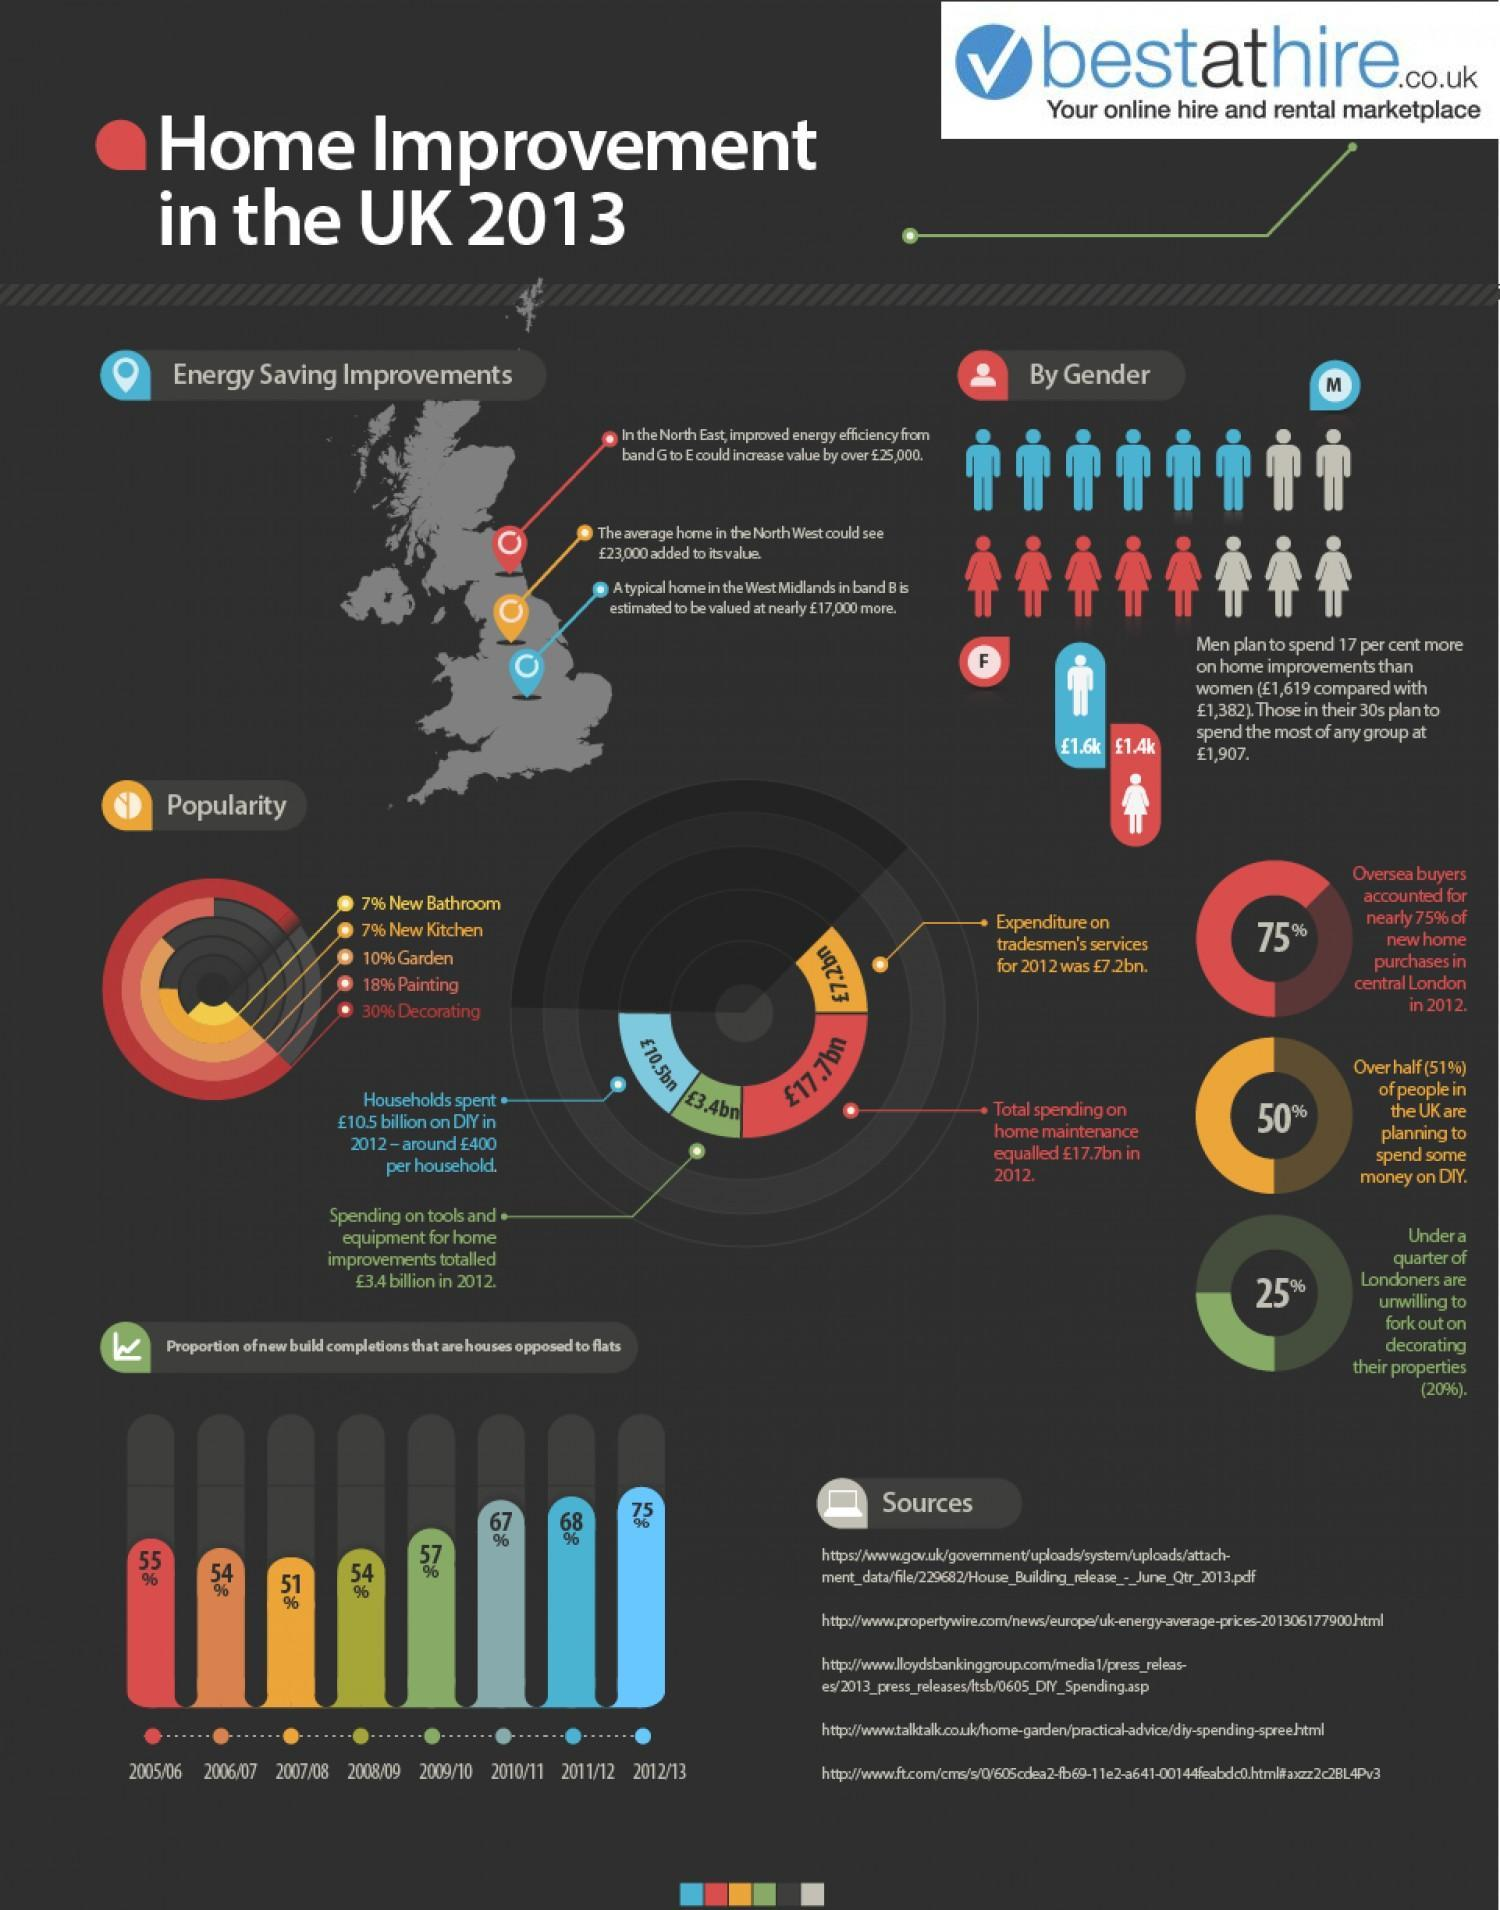What spending came to a total of 17.7 billion pounds in 2012?
Answer the question with a short phrase. home maintenance What was the second most commonly done work in home improvement? Painting Under 25% of Londoners are reluctant to spend money on what? decorating their properties In 2012, how many pounds were spent on tradesmen's services in UK? 7.2bn People in which age group are most likely to spend more money on home improvements? 30s Which is most commonly done in home improvement? decorating What percent of new home purchases were by oversea buyers? 75% What was the average spending per household (in pounds) in UK during the year 2012 on home improvements 400 What is the average amount (in pounds) spent by women on home improvements? 1,382 What was the spending (in pounds) on home improvement tools and equipment in 2012? 3.4 billion 